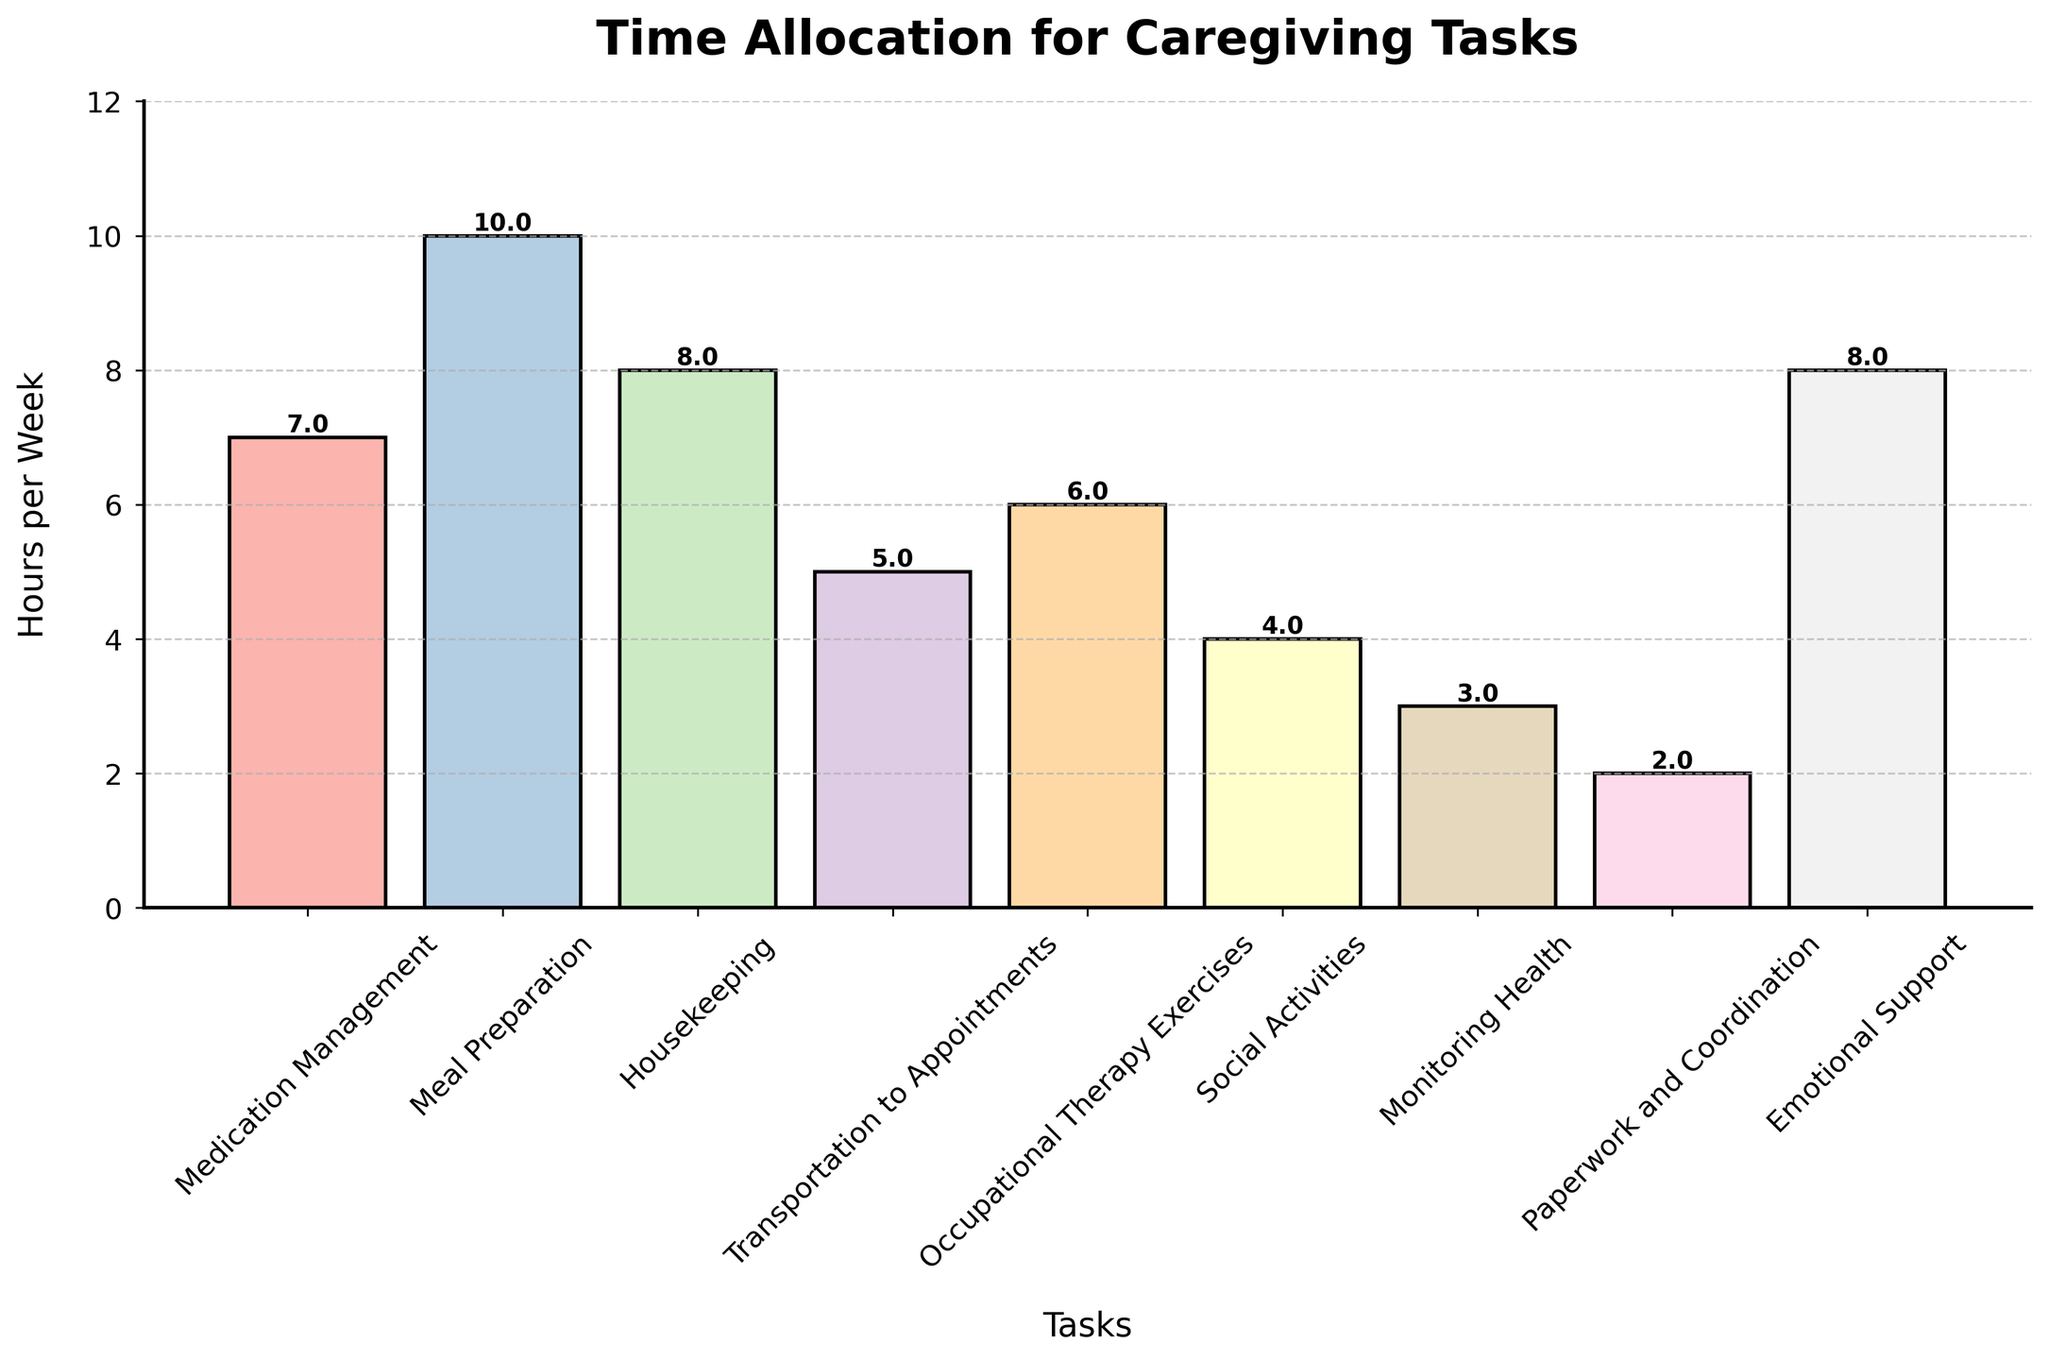What is the task that requires the most hours per week? Looking at the figure, the tallest bar represents the task that requires the most hours per week. The bar for "Meal Preparation" is the tallest.
Answer: Meal Preparation Which tasks require 8 hours per week? Observing the bars, those with a height of 8 hours per week represent the tasks. Both "Housekeeping" and "Emotional Support" have bars of this height.
Answer: Housekeeping, Emotional Support How many total hours are spent on "Medication Management" and "Monitoring Health" combined? Adding the hours for "Medication Management" (7 hours) and "Monitoring Health" (3 hours), we get the total. Sum: 7 + 3 = 10.
Answer: 10 Which task requires fewer hours: "Transportation to Appointments" or "Occupational Therapy Exercises"? Comparing the heights of the bars for "Transportation to Appointments" (5 hours) and "Occupational Therapy Exercises" (6 hours). The bar for "Transportation to Appointments" is shorter.
Answer: Transportation to Appointments What is the average number of hours spent on "Paperwork and Coordination" and "Social Activities"? Adding the hours for "Paperwork and Coordination" (2 hours) and "Social Activities" (4 hours), and then dividing by 2 to get the average. Sum: 2 + 4 = 6. Average: 6 / 2 = 3.
Answer: 3 How many more hours are spent on "Emotional Support" compared to "Monitoring Health"? Subtract the hours for "Monitoring Health" (3 hours) from the hours for "Emotional Support" (8 hours). Difference: 8 - 3 = 5.
Answer: 5 What tasks take equal amounts of time per week? Observing the bars, find those that have the same height. "Housekeeping" and "Emotional Support" both require 8 hours per week.
Answer: Housekeeping, Emotional Support Which color represents "Occupational Therapy Exercises"? The bar corresponding to "Occupational Therapy Exercises" should be identified by its unique color. The specific color is observed in the pastel color scheme used in the plot.
Answer: Pastel color (as it is not specified by a standard color name) Arrange tasks in ascending order based on hours per week. Sorting the tasks based on the height of the bars from shortest to tallest. The order is: "Paperwork and Coordination" (2), "Monitoring Health" (3), "Social Activities" (4), "Transportation to Appointments" (5), "Occupational Therapy Exercises" (6), "Medication Management" (7), "Housekeeping" (8), "Emotional Support" (8), and "Meal Preparation" (10).
Answer: Paperwork and Coordination, Monitoring Health, Social Activities, Transportation to Appointments, Occupational Therapy Exercises, Medication Management, Housekeeping, Emotional Support, Meal Preparation 